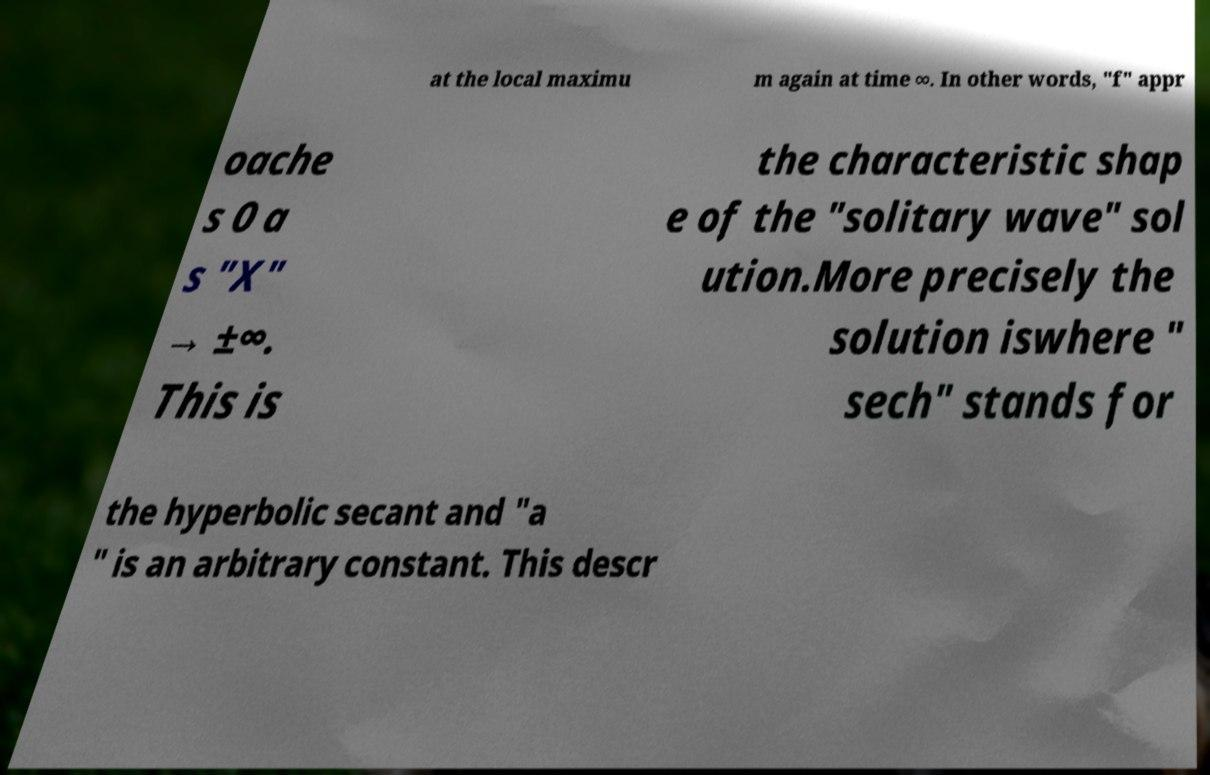Please identify and transcribe the text found in this image. at the local maximu m again at time ∞. In other words, "f" appr oache s 0 a s "X" → ±∞. This is the characteristic shap e of the "solitary wave" sol ution.More precisely the solution iswhere " sech" stands for the hyperbolic secant and "a " is an arbitrary constant. This descr 